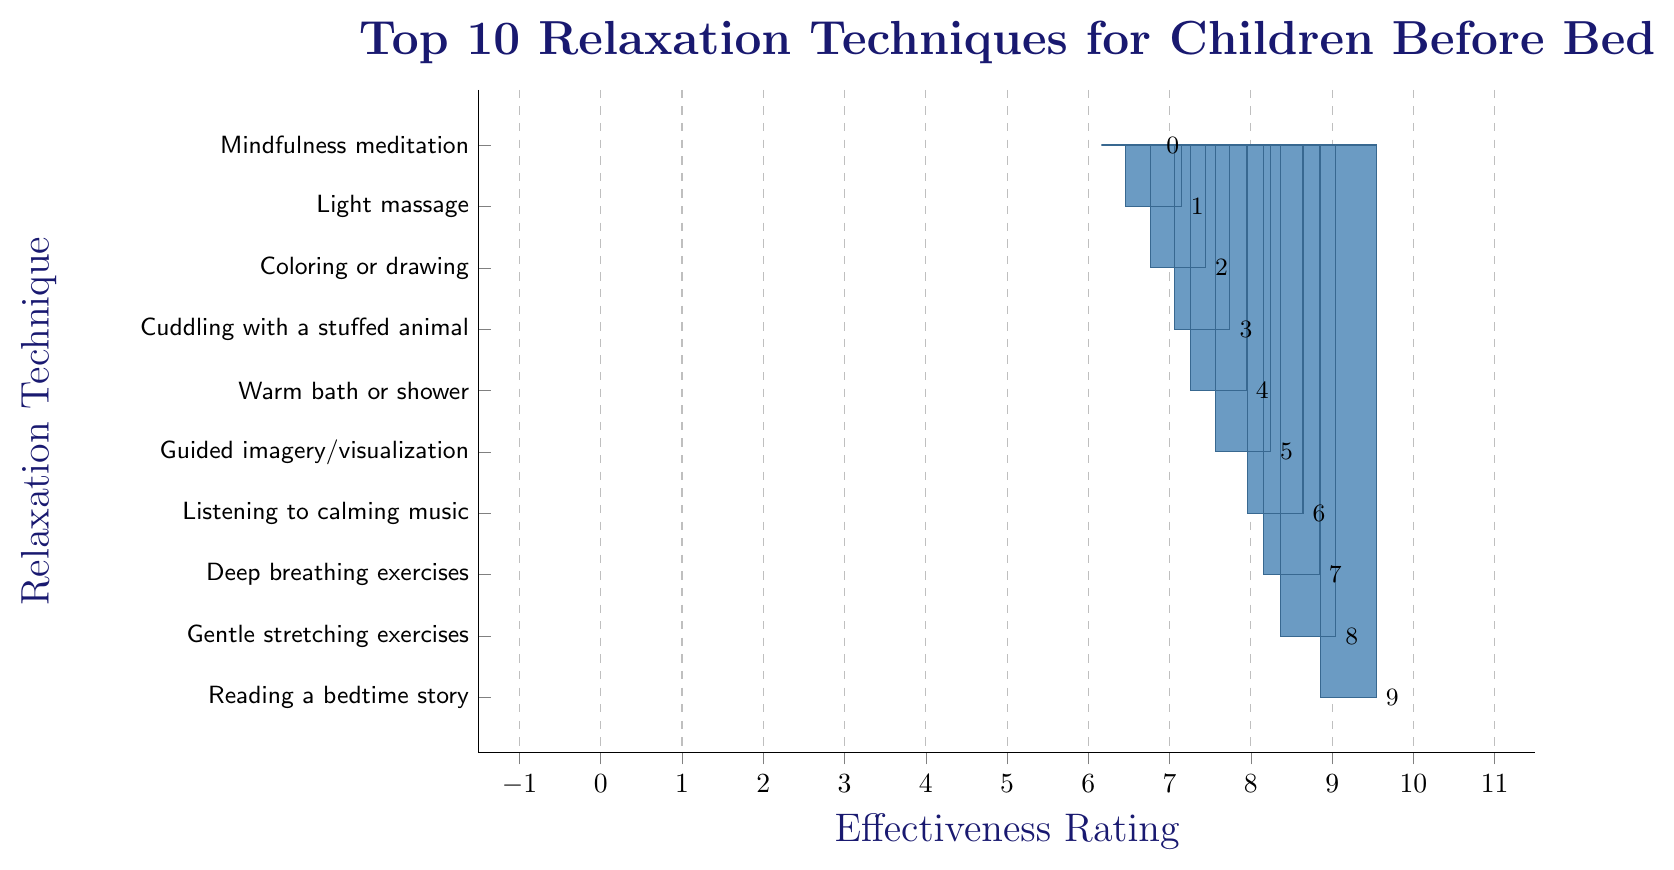Which relaxation technique has the highest effectiveness rating? The bar labeled “Reading a bedtime story” reaches the highest point on the chart, corresponding to an effectiveness rating of 9.2.
Answer: Reading a bedtime story Which two techniques are tied for the lowest effectiveness ratings? The bars for “Mindfulness meditation” and “Light massage” are the shortest, with effectiveness ratings of 6.5 and 6.8, respectively.
Answer: Mindfulness meditation, Light massage What is the difference in effectiveness rating between "Gentle stretching exercises" and "Cuddling with a stuffed animal"? The effectiveness rating of "Gentle stretching exercises" is 8.7 and "Cuddling with a stuffed animal" is 7.4. The difference is 8.7 - 7.4 = 1.3.
Answer: 1.3 How many techniques have an effectiveness rating above 8? Count the bars that exceed the 8-mark: "Reading a bedtime story", "Gentle stretching exercises", "Deep breathing exercises", and "Listening to calming music". There are 4 such techniques.
Answer: 4 Is "Guided imagery/visualization" more effective than "Coloring or drawing"? "Guided imagery/visualization" has an effectiveness rating of 7.9, while "Coloring or drawing" has 7.1, so yes, it is more effective.
Answer: Yes What is the average effectiveness rating of the top 5 relaxation techniques? The top 5 techniques are rated: 9.2, 8.7, 8.5, 8.3, and 7.9. Calculate the average: (9.2 + 8.7 + 8.5 + 8.3 + 7.9) / 5 = 42.6 / 5 = 8.52.
Answer: 8.52 How does "Warm bath or shower" compare to the average effectiveness rating of all techniques? First, calculate the average effectiveness rating of all techniques: (9.2 + 8.7 + 8.5 + 8.3 + 7.9 + 7.6 + 7.4 + 7.1 + 6.8 + 6.5) / 10 = 77 / 10 = 7.7. "Warm bath or shower" has a rating of 7.6, which is just below the average of 7.7.
Answer: Below 